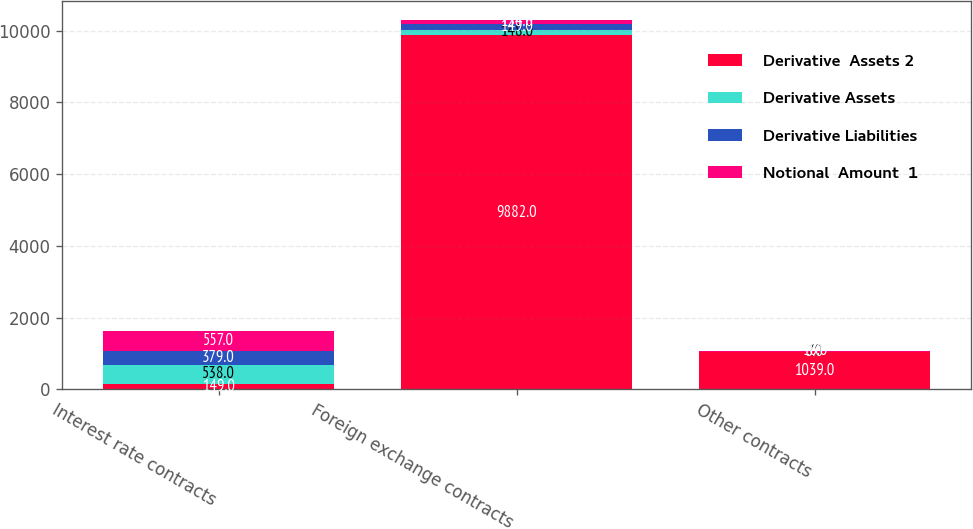Convert chart to OTSL. <chart><loc_0><loc_0><loc_500><loc_500><stacked_bar_chart><ecel><fcel>Interest rate contracts<fcel>Foreign exchange contracts<fcel>Other contracts<nl><fcel>Derivative  Assets 2<fcel>149<fcel>9882<fcel>1039<nl><fcel>Derivative Assets<fcel>538<fcel>148<fcel>7<nl><fcel>Derivative Liabilities<fcel>379<fcel>149<fcel>5<nl><fcel>Notional  Amount  1<fcel>557<fcel>134<fcel>16<nl></chart> 